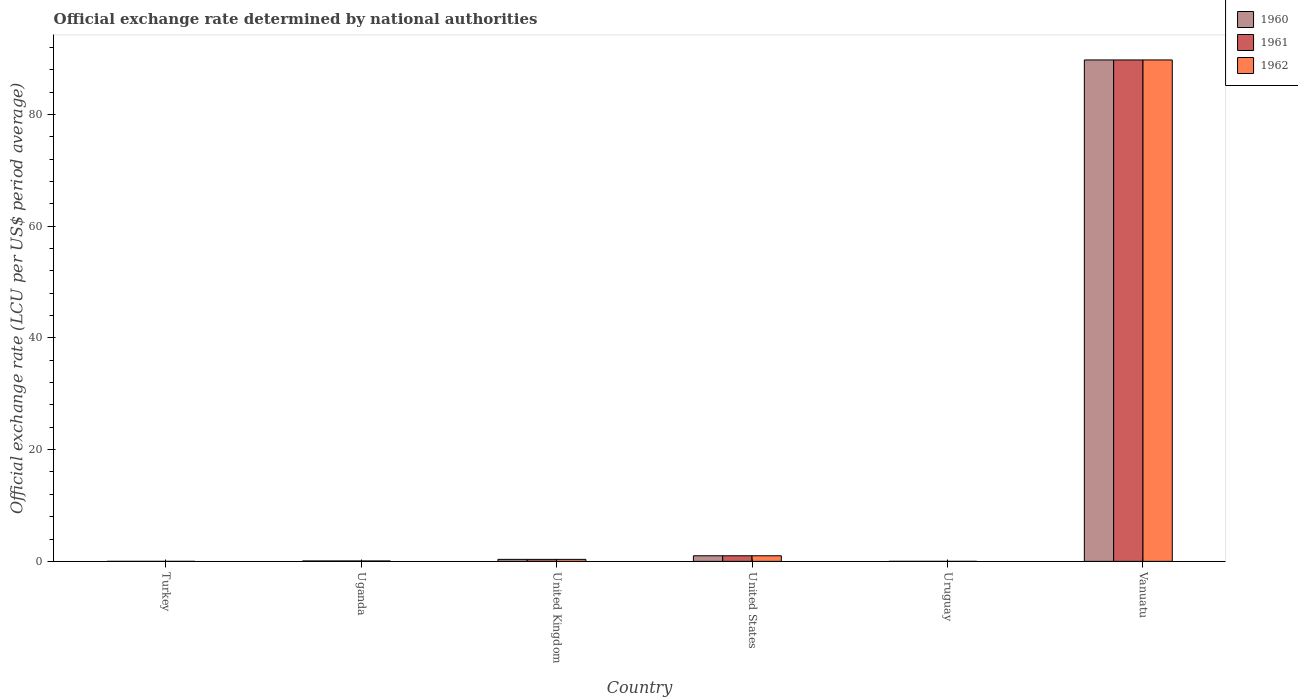How many different coloured bars are there?
Make the answer very short. 3. How many groups of bars are there?
Make the answer very short. 6. Are the number of bars per tick equal to the number of legend labels?
Give a very brief answer. Yes. Are the number of bars on each tick of the X-axis equal?
Your answer should be compact. Yes. How many bars are there on the 6th tick from the right?
Offer a very short reply. 3. What is the official exchange rate in 1961 in Turkey?
Keep it short and to the point. 9.02e-6. Across all countries, what is the maximum official exchange rate in 1960?
Ensure brevity in your answer.  89.77. Across all countries, what is the minimum official exchange rate in 1962?
Offer a terse response. 9.02e-6. In which country was the official exchange rate in 1961 maximum?
Keep it short and to the point. Vanuatu. What is the total official exchange rate in 1960 in the graph?
Provide a succinct answer. 91.19. What is the difference between the official exchange rate in 1960 in United Kingdom and that in United States?
Your answer should be very brief. -0.64. What is the difference between the official exchange rate in 1961 in Uruguay and the official exchange rate in 1962 in United States?
Offer a terse response. -1. What is the average official exchange rate in 1961 per country?
Your response must be concise. 15.2. What is the ratio of the official exchange rate in 1960 in Turkey to that in United States?
Your answer should be very brief. 9.01691666658333e-6. What is the difference between the highest and the second highest official exchange rate in 1962?
Keep it short and to the point. -89.41. What is the difference between the highest and the lowest official exchange rate in 1962?
Keep it short and to the point. 89.76. In how many countries, is the official exchange rate in 1961 greater than the average official exchange rate in 1961 taken over all countries?
Your answer should be very brief. 1. Is it the case that in every country, the sum of the official exchange rate in 1961 and official exchange rate in 1960 is greater than the official exchange rate in 1962?
Keep it short and to the point. Yes. How many bars are there?
Keep it short and to the point. 18. Are all the bars in the graph horizontal?
Provide a succinct answer. No. What is the difference between two consecutive major ticks on the Y-axis?
Provide a short and direct response. 20. How many legend labels are there?
Your answer should be very brief. 3. How are the legend labels stacked?
Provide a short and direct response. Vertical. What is the title of the graph?
Your answer should be very brief. Official exchange rate determined by national authorities. What is the label or title of the Y-axis?
Provide a short and direct response. Official exchange rate (LCU per US$ period average). What is the Official exchange rate (LCU per US$ period average) of 1960 in Turkey?
Ensure brevity in your answer.  9.01691666658333e-6. What is the Official exchange rate (LCU per US$ period average) in 1961 in Turkey?
Offer a terse response. 9.02e-6. What is the Official exchange rate (LCU per US$ period average) in 1962 in Turkey?
Your response must be concise. 9.02e-6. What is the Official exchange rate (LCU per US$ period average) in 1960 in Uganda?
Offer a terse response. 0.07. What is the Official exchange rate (LCU per US$ period average) of 1961 in Uganda?
Keep it short and to the point. 0.07. What is the Official exchange rate (LCU per US$ period average) of 1962 in Uganda?
Make the answer very short. 0.07. What is the Official exchange rate (LCU per US$ period average) in 1960 in United Kingdom?
Give a very brief answer. 0.36. What is the Official exchange rate (LCU per US$ period average) of 1961 in United Kingdom?
Offer a very short reply. 0.36. What is the Official exchange rate (LCU per US$ period average) of 1962 in United Kingdom?
Give a very brief answer. 0.36. What is the Official exchange rate (LCU per US$ period average) in 1962 in United States?
Give a very brief answer. 1. What is the Official exchange rate (LCU per US$ period average) in 1960 in Uruguay?
Give a very brief answer. 1.12966666666667e-5. What is the Official exchange rate (LCU per US$ period average) of 1961 in Uruguay?
Keep it short and to the point. 1.10091666666667e-5. What is the Official exchange rate (LCU per US$ period average) of 1962 in Uruguay?
Offer a terse response. 1.098e-5. What is the Official exchange rate (LCU per US$ period average) in 1960 in Vanuatu?
Keep it short and to the point. 89.77. What is the Official exchange rate (LCU per US$ period average) of 1961 in Vanuatu?
Ensure brevity in your answer.  89.77. What is the Official exchange rate (LCU per US$ period average) of 1962 in Vanuatu?
Keep it short and to the point. 89.77. Across all countries, what is the maximum Official exchange rate (LCU per US$ period average) in 1960?
Provide a short and direct response. 89.77. Across all countries, what is the maximum Official exchange rate (LCU per US$ period average) of 1961?
Provide a succinct answer. 89.77. Across all countries, what is the maximum Official exchange rate (LCU per US$ period average) in 1962?
Your answer should be compact. 89.77. Across all countries, what is the minimum Official exchange rate (LCU per US$ period average) of 1960?
Give a very brief answer. 9.01691666658333e-6. Across all countries, what is the minimum Official exchange rate (LCU per US$ period average) of 1961?
Offer a very short reply. 9.02e-6. Across all countries, what is the minimum Official exchange rate (LCU per US$ period average) in 1962?
Your answer should be compact. 9.02e-6. What is the total Official exchange rate (LCU per US$ period average) in 1960 in the graph?
Your answer should be compact. 91.19. What is the total Official exchange rate (LCU per US$ period average) in 1961 in the graph?
Provide a short and direct response. 91.19. What is the total Official exchange rate (LCU per US$ period average) of 1962 in the graph?
Provide a succinct answer. 91.19. What is the difference between the Official exchange rate (LCU per US$ period average) in 1960 in Turkey and that in Uganda?
Provide a succinct answer. -0.07. What is the difference between the Official exchange rate (LCU per US$ period average) of 1961 in Turkey and that in Uganda?
Offer a terse response. -0.07. What is the difference between the Official exchange rate (LCU per US$ period average) in 1962 in Turkey and that in Uganda?
Your answer should be very brief. -0.07. What is the difference between the Official exchange rate (LCU per US$ period average) of 1960 in Turkey and that in United Kingdom?
Offer a very short reply. -0.36. What is the difference between the Official exchange rate (LCU per US$ period average) of 1961 in Turkey and that in United Kingdom?
Your answer should be very brief. -0.36. What is the difference between the Official exchange rate (LCU per US$ period average) in 1962 in Turkey and that in United Kingdom?
Keep it short and to the point. -0.36. What is the difference between the Official exchange rate (LCU per US$ period average) in 1960 in Turkey and that in United States?
Offer a very short reply. -1. What is the difference between the Official exchange rate (LCU per US$ period average) in 1961 in Turkey and that in United States?
Keep it short and to the point. -1. What is the difference between the Official exchange rate (LCU per US$ period average) of 1960 in Turkey and that in Uruguay?
Ensure brevity in your answer.  -0. What is the difference between the Official exchange rate (LCU per US$ period average) of 1962 in Turkey and that in Uruguay?
Your answer should be compact. -0. What is the difference between the Official exchange rate (LCU per US$ period average) of 1960 in Turkey and that in Vanuatu?
Provide a succinct answer. -89.77. What is the difference between the Official exchange rate (LCU per US$ period average) in 1961 in Turkey and that in Vanuatu?
Provide a succinct answer. -89.77. What is the difference between the Official exchange rate (LCU per US$ period average) of 1962 in Turkey and that in Vanuatu?
Offer a very short reply. -89.77. What is the difference between the Official exchange rate (LCU per US$ period average) of 1960 in Uganda and that in United Kingdom?
Give a very brief answer. -0.29. What is the difference between the Official exchange rate (LCU per US$ period average) in 1961 in Uganda and that in United Kingdom?
Provide a succinct answer. -0.29. What is the difference between the Official exchange rate (LCU per US$ period average) in 1962 in Uganda and that in United Kingdom?
Provide a short and direct response. -0.29. What is the difference between the Official exchange rate (LCU per US$ period average) of 1960 in Uganda and that in United States?
Make the answer very short. -0.93. What is the difference between the Official exchange rate (LCU per US$ period average) of 1961 in Uganda and that in United States?
Give a very brief answer. -0.93. What is the difference between the Official exchange rate (LCU per US$ period average) of 1962 in Uganda and that in United States?
Provide a succinct answer. -0.93. What is the difference between the Official exchange rate (LCU per US$ period average) in 1960 in Uganda and that in Uruguay?
Your answer should be compact. 0.07. What is the difference between the Official exchange rate (LCU per US$ period average) of 1961 in Uganda and that in Uruguay?
Your response must be concise. 0.07. What is the difference between the Official exchange rate (LCU per US$ period average) in 1962 in Uganda and that in Uruguay?
Offer a very short reply. 0.07. What is the difference between the Official exchange rate (LCU per US$ period average) in 1960 in Uganda and that in Vanuatu?
Give a very brief answer. -89.69. What is the difference between the Official exchange rate (LCU per US$ period average) of 1961 in Uganda and that in Vanuatu?
Your response must be concise. -89.69. What is the difference between the Official exchange rate (LCU per US$ period average) in 1962 in Uganda and that in Vanuatu?
Provide a short and direct response. -89.69. What is the difference between the Official exchange rate (LCU per US$ period average) in 1960 in United Kingdom and that in United States?
Make the answer very short. -0.64. What is the difference between the Official exchange rate (LCU per US$ period average) in 1961 in United Kingdom and that in United States?
Your answer should be very brief. -0.64. What is the difference between the Official exchange rate (LCU per US$ period average) in 1962 in United Kingdom and that in United States?
Keep it short and to the point. -0.64. What is the difference between the Official exchange rate (LCU per US$ period average) of 1960 in United Kingdom and that in Uruguay?
Offer a terse response. 0.36. What is the difference between the Official exchange rate (LCU per US$ period average) of 1961 in United Kingdom and that in Uruguay?
Offer a very short reply. 0.36. What is the difference between the Official exchange rate (LCU per US$ period average) of 1962 in United Kingdom and that in Uruguay?
Ensure brevity in your answer.  0.36. What is the difference between the Official exchange rate (LCU per US$ period average) of 1960 in United Kingdom and that in Vanuatu?
Offer a very short reply. -89.41. What is the difference between the Official exchange rate (LCU per US$ period average) of 1961 in United Kingdom and that in Vanuatu?
Your answer should be very brief. -89.41. What is the difference between the Official exchange rate (LCU per US$ period average) in 1962 in United Kingdom and that in Vanuatu?
Keep it short and to the point. -89.41. What is the difference between the Official exchange rate (LCU per US$ period average) of 1960 in United States and that in Uruguay?
Keep it short and to the point. 1. What is the difference between the Official exchange rate (LCU per US$ period average) in 1960 in United States and that in Vanuatu?
Your answer should be very brief. -88.77. What is the difference between the Official exchange rate (LCU per US$ period average) in 1961 in United States and that in Vanuatu?
Ensure brevity in your answer.  -88.77. What is the difference between the Official exchange rate (LCU per US$ period average) of 1962 in United States and that in Vanuatu?
Offer a terse response. -88.77. What is the difference between the Official exchange rate (LCU per US$ period average) of 1960 in Uruguay and that in Vanuatu?
Your answer should be very brief. -89.77. What is the difference between the Official exchange rate (LCU per US$ period average) of 1961 in Uruguay and that in Vanuatu?
Your response must be concise. -89.77. What is the difference between the Official exchange rate (LCU per US$ period average) in 1962 in Uruguay and that in Vanuatu?
Offer a very short reply. -89.77. What is the difference between the Official exchange rate (LCU per US$ period average) in 1960 in Turkey and the Official exchange rate (LCU per US$ period average) in 1961 in Uganda?
Provide a short and direct response. -0.07. What is the difference between the Official exchange rate (LCU per US$ period average) of 1960 in Turkey and the Official exchange rate (LCU per US$ period average) of 1962 in Uganda?
Your answer should be compact. -0.07. What is the difference between the Official exchange rate (LCU per US$ period average) in 1961 in Turkey and the Official exchange rate (LCU per US$ period average) in 1962 in Uganda?
Your answer should be compact. -0.07. What is the difference between the Official exchange rate (LCU per US$ period average) in 1960 in Turkey and the Official exchange rate (LCU per US$ period average) in 1961 in United Kingdom?
Provide a short and direct response. -0.36. What is the difference between the Official exchange rate (LCU per US$ period average) of 1960 in Turkey and the Official exchange rate (LCU per US$ period average) of 1962 in United Kingdom?
Your answer should be compact. -0.36. What is the difference between the Official exchange rate (LCU per US$ period average) in 1961 in Turkey and the Official exchange rate (LCU per US$ period average) in 1962 in United Kingdom?
Make the answer very short. -0.36. What is the difference between the Official exchange rate (LCU per US$ period average) of 1960 in Turkey and the Official exchange rate (LCU per US$ period average) of 1961 in United States?
Give a very brief answer. -1. What is the difference between the Official exchange rate (LCU per US$ period average) of 1960 in Turkey and the Official exchange rate (LCU per US$ period average) of 1962 in United States?
Make the answer very short. -1. What is the difference between the Official exchange rate (LCU per US$ period average) of 1961 in Turkey and the Official exchange rate (LCU per US$ period average) of 1962 in United States?
Ensure brevity in your answer.  -1. What is the difference between the Official exchange rate (LCU per US$ period average) in 1960 in Turkey and the Official exchange rate (LCU per US$ period average) in 1962 in Uruguay?
Your response must be concise. -0. What is the difference between the Official exchange rate (LCU per US$ period average) in 1961 in Turkey and the Official exchange rate (LCU per US$ period average) in 1962 in Uruguay?
Make the answer very short. -0. What is the difference between the Official exchange rate (LCU per US$ period average) of 1960 in Turkey and the Official exchange rate (LCU per US$ period average) of 1961 in Vanuatu?
Your answer should be compact. -89.77. What is the difference between the Official exchange rate (LCU per US$ period average) in 1960 in Turkey and the Official exchange rate (LCU per US$ period average) in 1962 in Vanuatu?
Offer a very short reply. -89.77. What is the difference between the Official exchange rate (LCU per US$ period average) in 1961 in Turkey and the Official exchange rate (LCU per US$ period average) in 1962 in Vanuatu?
Provide a succinct answer. -89.77. What is the difference between the Official exchange rate (LCU per US$ period average) of 1960 in Uganda and the Official exchange rate (LCU per US$ period average) of 1961 in United Kingdom?
Offer a terse response. -0.29. What is the difference between the Official exchange rate (LCU per US$ period average) of 1960 in Uganda and the Official exchange rate (LCU per US$ period average) of 1962 in United Kingdom?
Ensure brevity in your answer.  -0.29. What is the difference between the Official exchange rate (LCU per US$ period average) in 1961 in Uganda and the Official exchange rate (LCU per US$ period average) in 1962 in United Kingdom?
Ensure brevity in your answer.  -0.29. What is the difference between the Official exchange rate (LCU per US$ period average) in 1960 in Uganda and the Official exchange rate (LCU per US$ period average) in 1961 in United States?
Keep it short and to the point. -0.93. What is the difference between the Official exchange rate (LCU per US$ period average) in 1960 in Uganda and the Official exchange rate (LCU per US$ period average) in 1962 in United States?
Offer a very short reply. -0.93. What is the difference between the Official exchange rate (LCU per US$ period average) of 1961 in Uganda and the Official exchange rate (LCU per US$ period average) of 1962 in United States?
Provide a succinct answer. -0.93. What is the difference between the Official exchange rate (LCU per US$ period average) in 1960 in Uganda and the Official exchange rate (LCU per US$ period average) in 1961 in Uruguay?
Your answer should be very brief. 0.07. What is the difference between the Official exchange rate (LCU per US$ period average) in 1960 in Uganda and the Official exchange rate (LCU per US$ period average) in 1962 in Uruguay?
Keep it short and to the point. 0.07. What is the difference between the Official exchange rate (LCU per US$ period average) in 1961 in Uganda and the Official exchange rate (LCU per US$ period average) in 1962 in Uruguay?
Provide a short and direct response. 0.07. What is the difference between the Official exchange rate (LCU per US$ period average) of 1960 in Uganda and the Official exchange rate (LCU per US$ period average) of 1961 in Vanuatu?
Offer a terse response. -89.69. What is the difference between the Official exchange rate (LCU per US$ period average) in 1960 in Uganda and the Official exchange rate (LCU per US$ period average) in 1962 in Vanuatu?
Your response must be concise. -89.69. What is the difference between the Official exchange rate (LCU per US$ period average) of 1961 in Uganda and the Official exchange rate (LCU per US$ period average) of 1962 in Vanuatu?
Offer a terse response. -89.69. What is the difference between the Official exchange rate (LCU per US$ period average) of 1960 in United Kingdom and the Official exchange rate (LCU per US$ period average) of 1961 in United States?
Give a very brief answer. -0.64. What is the difference between the Official exchange rate (LCU per US$ period average) of 1960 in United Kingdom and the Official exchange rate (LCU per US$ period average) of 1962 in United States?
Keep it short and to the point. -0.64. What is the difference between the Official exchange rate (LCU per US$ period average) in 1961 in United Kingdom and the Official exchange rate (LCU per US$ period average) in 1962 in United States?
Your answer should be very brief. -0.64. What is the difference between the Official exchange rate (LCU per US$ period average) of 1960 in United Kingdom and the Official exchange rate (LCU per US$ period average) of 1961 in Uruguay?
Keep it short and to the point. 0.36. What is the difference between the Official exchange rate (LCU per US$ period average) of 1960 in United Kingdom and the Official exchange rate (LCU per US$ period average) of 1962 in Uruguay?
Your response must be concise. 0.36. What is the difference between the Official exchange rate (LCU per US$ period average) in 1961 in United Kingdom and the Official exchange rate (LCU per US$ period average) in 1962 in Uruguay?
Your response must be concise. 0.36. What is the difference between the Official exchange rate (LCU per US$ period average) in 1960 in United Kingdom and the Official exchange rate (LCU per US$ period average) in 1961 in Vanuatu?
Give a very brief answer. -89.41. What is the difference between the Official exchange rate (LCU per US$ period average) of 1960 in United Kingdom and the Official exchange rate (LCU per US$ period average) of 1962 in Vanuatu?
Keep it short and to the point. -89.41. What is the difference between the Official exchange rate (LCU per US$ period average) of 1961 in United Kingdom and the Official exchange rate (LCU per US$ period average) of 1962 in Vanuatu?
Ensure brevity in your answer.  -89.41. What is the difference between the Official exchange rate (LCU per US$ period average) in 1960 in United States and the Official exchange rate (LCU per US$ period average) in 1961 in Uruguay?
Make the answer very short. 1. What is the difference between the Official exchange rate (LCU per US$ period average) of 1961 in United States and the Official exchange rate (LCU per US$ period average) of 1962 in Uruguay?
Offer a terse response. 1. What is the difference between the Official exchange rate (LCU per US$ period average) of 1960 in United States and the Official exchange rate (LCU per US$ period average) of 1961 in Vanuatu?
Offer a terse response. -88.77. What is the difference between the Official exchange rate (LCU per US$ period average) in 1960 in United States and the Official exchange rate (LCU per US$ period average) in 1962 in Vanuatu?
Your answer should be compact. -88.77. What is the difference between the Official exchange rate (LCU per US$ period average) of 1961 in United States and the Official exchange rate (LCU per US$ period average) of 1962 in Vanuatu?
Keep it short and to the point. -88.77. What is the difference between the Official exchange rate (LCU per US$ period average) in 1960 in Uruguay and the Official exchange rate (LCU per US$ period average) in 1961 in Vanuatu?
Your answer should be very brief. -89.77. What is the difference between the Official exchange rate (LCU per US$ period average) of 1960 in Uruguay and the Official exchange rate (LCU per US$ period average) of 1962 in Vanuatu?
Your response must be concise. -89.77. What is the difference between the Official exchange rate (LCU per US$ period average) of 1961 in Uruguay and the Official exchange rate (LCU per US$ period average) of 1962 in Vanuatu?
Keep it short and to the point. -89.77. What is the average Official exchange rate (LCU per US$ period average) in 1960 per country?
Offer a terse response. 15.2. What is the average Official exchange rate (LCU per US$ period average) in 1961 per country?
Ensure brevity in your answer.  15.2. What is the average Official exchange rate (LCU per US$ period average) in 1962 per country?
Your answer should be compact. 15.2. What is the difference between the Official exchange rate (LCU per US$ period average) in 1960 and Official exchange rate (LCU per US$ period average) in 1962 in Turkey?
Offer a terse response. -0. What is the difference between the Official exchange rate (LCU per US$ period average) of 1961 and Official exchange rate (LCU per US$ period average) of 1962 in Turkey?
Your response must be concise. 0. What is the difference between the Official exchange rate (LCU per US$ period average) of 1960 and Official exchange rate (LCU per US$ period average) of 1961 in United Kingdom?
Make the answer very short. 0. What is the difference between the Official exchange rate (LCU per US$ period average) of 1960 and Official exchange rate (LCU per US$ period average) of 1962 in United Kingdom?
Ensure brevity in your answer.  0. What is the difference between the Official exchange rate (LCU per US$ period average) of 1960 and Official exchange rate (LCU per US$ period average) of 1962 in United States?
Keep it short and to the point. 0. What is the difference between the Official exchange rate (LCU per US$ period average) in 1961 and Official exchange rate (LCU per US$ period average) in 1962 in United States?
Make the answer very short. 0. What is the difference between the Official exchange rate (LCU per US$ period average) of 1960 and Official exchange rate (LCU per US$ period average) of 1962 in Uruguay?
Your response must be concise. 0. What is the ratio of the Official exchange rate (LCU per US$ period average) of 1961 in Turkey to that in Uganda?
Provide a short and direct response. 0. What is the ratio of the Official exchange rate (LCU per US$ period average) of 1962 in Turkey to that in Uganda?
Give a very brief answer. 0. What is the ratio of the Official exchange rate (LCU per US$ period average) of 1960 in Turkey to that in United Kingdom?
Give a very brief answer. 0. What is the ratio of the Official exchange rate (LCU per US$ period average) of 1961 in Turkey to that in United Kingdom?
Give a very brief answer. 0. What is the ratio of the Official exchange rate (LCU per US$ period average) of 1962 in Turkey to that in United Kingdom?
Give a very brief answer. 0. What is the ratio of the Official exchange rate (LCU per US$ period average) in 1962 in Turkey to that in United States?
Your answer should be compact. 0. What is the ratio of the Official exchange rate (LCU per US$ period average) of 1960 in Turkey to that in Uruguay?
Make the answer very short. 0.8. What is the ratio of the Official exchange rate (LCU per US$ period average) of 1961 in Turkey to that in Uruguay?
Your answer should be very brief. 0.82. What is the ratio of the Official exchange rate (LCU per US$ period average) in 1962 in Turkey to that in Uruguay?
Your answer should be very brief. 0.82. What is the ratio of the Official exchange rate (LCU per US$ period average) of 1960 in Turkey to that in Vanuatu?
Provide a short and direct response. 0. What is the ratio of the Official exchange rate (LCU per US$ period average) in 1961 in Turkey to that in Vanuatu?
Offer a terse response. 0. What is the ratio of the Official exchange rate (LCU per US$ period average) of 1962 in Turkey to that in Vanuatu?
Provide a succinct answer. 0. What is the ratio of the Official exchange rate (LCU per US$ period average) in 1960 in Uganda to that in United States?
Offer a very short reply. 0.07. What is the ratio of the Official exchange rate (LCU per US$ period average) of 1961 in Uganda to that in United States?
Offer a terse response. 0.07. What is the ratio of the Official exchange rate (LCU per US$ period average) of 1962 in Uganda to that in United States?
Your response must be concise. 0.07. What is the ratio of the Official exchange rate (LCU per US$ period average) in 1960 in Uganda to that in Uruguay?
Give a very brief answer. 6323.1. What is the ratio of the Official exchange rate (LCU per US$ period average) of 1961 in Uganda to that in Uruguay?
Offer a terse response. 6488.23. What is the ratio of the Official exchange rate (LCU per US$ period average) of 1962 in Uganda to that in Uruguay?
Provide a succinct answer. 6505.46. What is the ratio of the Official exchange rate (LCU per US$ period average) in 1960 in Uganda to that in Vanuatu?
Your answer should be compact. 0. What is the ratio of the Official exchange rate (LCU per US$ period average) of 1961 in Uganda to that in Vanuatu?
Offer a very short reply. 0. What is the ratio of the Official exchange rate (LCU per US$ period average) of 1962 in Uganda to that in Vanuatu?
Your answer should be compact. 0. What is the ratio of the Official exchange rate (LCU per US$ period average) in 1960 in United Kingdom to that in United States?
Offer a very short reply. 0.36. What is the ratio of the Official exchange rate (LCU per US$ period average) in 1961 in United Kingdom to that in United States?
Your answer should be compact. 0.36. What is the ratio of the Official exchange rate (LCU per US$ period average) in 1962 in United Kingdom to that in United States?
Ensure brevity in your answer.  0.36. What is the ratio of the Official exchange rate (LCU per US$ period average) of 1960 in United Kingdom to that in Uruguay?
Your answer should be compact. 3.16e+04. What is the ratio of the Official exchange rate (LCU per US$ period average) in 1961 in United Kingdom to that in Uruguay?
Offer a very short reply. 3.24e+04. What is the ratio of the Official exchange rate (LCU per US$ period average) of 1962 in United Kingdom to that in Uruguay?
Provide a succinct answer. 3.25e+04. What is the ratio of the Official exchange rate (LCU per US$ period average) in 1960 in United Kingdom to that in Vanuatu?
Offer a terse response. 0. What is the ratio of the Official exchange rate (LCU per US$ period average) in 1961 in United Kingdom to that in Vanuatu?
Offer a very short reply. 0. What is the ratio of the Official exchange rate (LCU per US$ period average) of 1962 in United Kingdom to that in Vanuatu?
Ensure brevity in your answer.  0. What is the ratio of the Official exchange rate (LCU per US$ period average) in 1960 in United States to that in Uruguay?
Provide a succinct answer. 8.85e+04. What is the ratio of the Official exchange rate (LCU per US$ period average) in 1961 in United States to that in Uruguay?
Ensure brevity in your answer.  9.08e+04. What is the ratio of the Official exchange rate (LCU per US$ period average) of 1962 in United States to that in Uruguay?
Make the answer very short. 9.11e+04. What is the ratio of the Official exchange rate (LCU per US$ period average) of 1960 in United States to that in Vanuatu?
Your response must be concise. 0.01. What is the ratio of the Official exchange rate (LCU per US$ period average) in 1961 in United States to that in Vanuatu?
Your answer should be compact. 0.01. What is the ratio of the Official exchange rate (LCU per US$ period average) in 1962 in United States to that in Vanuatu?
Give a very brief answer. 0.01. What is the ratio of the Official exchange rate (LCU per US$ period average) in 1961 in Uruguay to that in Vanuatu?
Offer a terse response. 0. What is the difference between the highest and the second highest Official exchange rate (LCU per US$ period average) of 1960?
Your response must be concise. 88.77. What is the difference between the highest and the second highest Official exchange rate (LCU per US$ period average) of 1961?
Offer a terse response. 88.77. What is the difference between the highest and the second highest Official exchange rate (LCU per US$ period average) in 1962?
Keep it short and to the point. 88.77. What is the difference between the highest and the lowest Official exchange rate (LCU per US$ period average) in 1960?
Keep it short and to the point. 89.77. What is the difference between the highest and the lowest Official exchange rate (LCU per US$ period average) in 1961?
Keep it short and to the point. 89.77. What is the difference between the highest and the lowest Official exchange rate (LCU per US$ period average) in 1962?
Your answer should be compact. 89.77. 